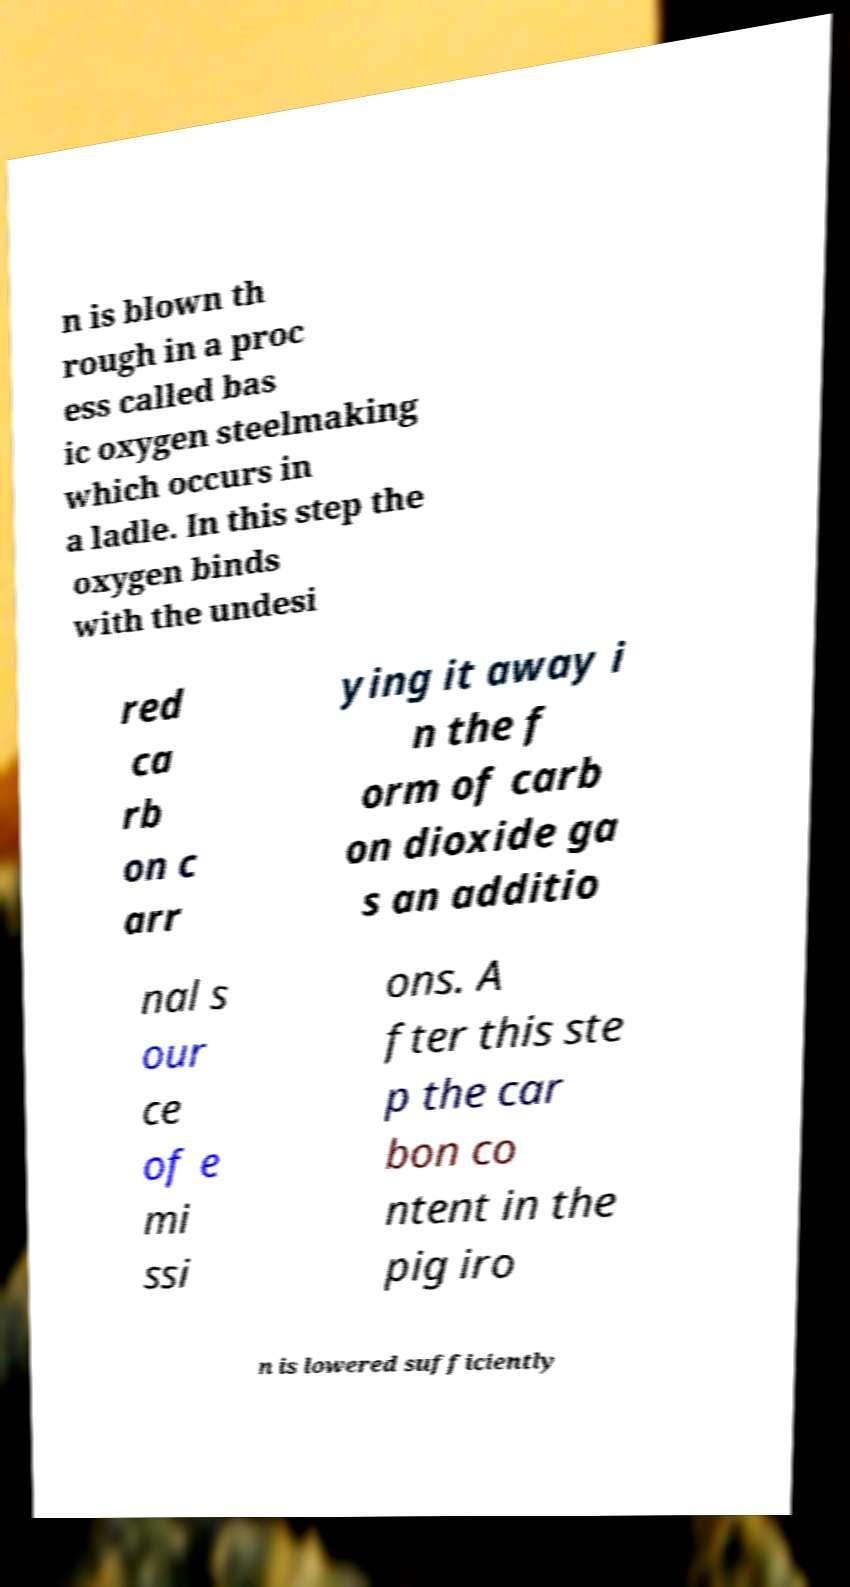Please read and relay the text visible in this image. What does it say? n is blown th rough in a proc ess called bas ic oxygen steelmaking which occurs in a ladle. In this step the oxygen binds with the undesi red ca rb on c arr ying it away i n the f orm of carb on dioxide ga s an additio nal s our ce of e mi ssi ons. A fter this ste p the car bon co ntent in the pig iro n is lowered sufficiently 